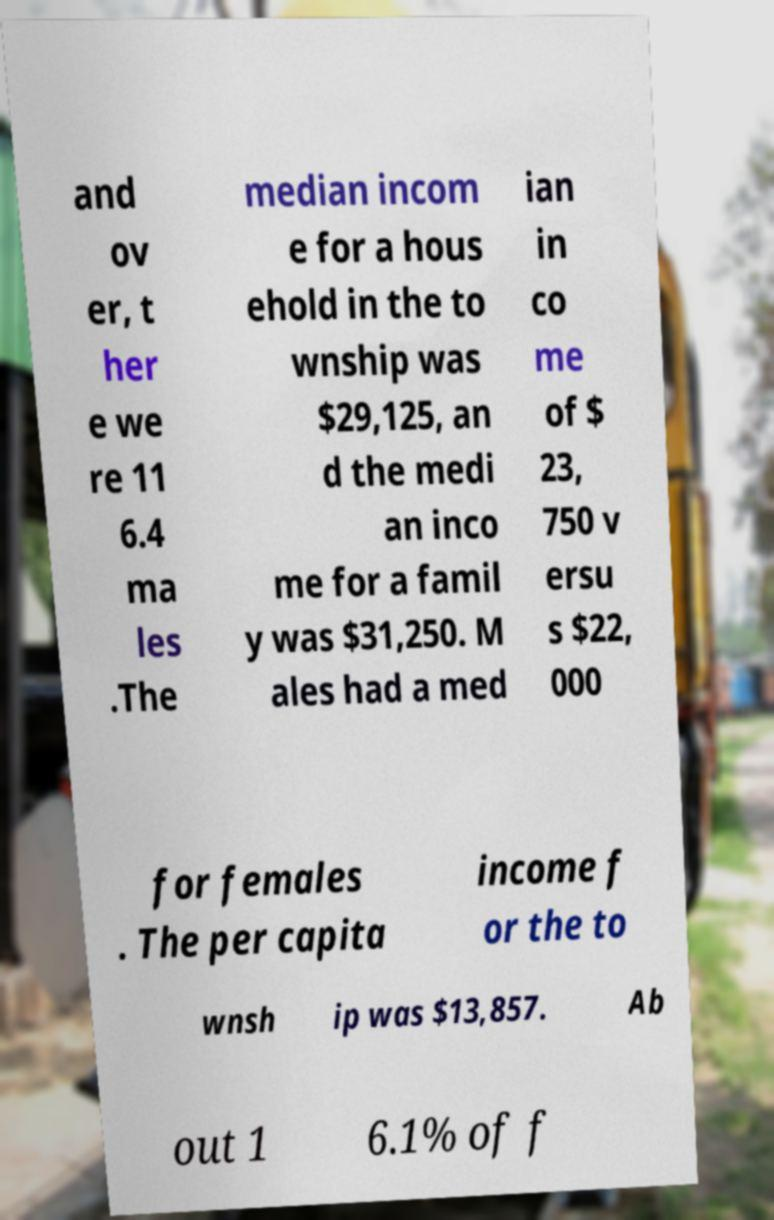Please read and relay the text visible in this image. What does it say? and ov er, t her e we re 11 6.4 ma les .The median incom e for a hous ehold in the to wnship was $29,125, an d the medi an inco me for a famil y was $31,250. M ales had a med ian in co me of $ 23, 750 v ersu s $22, 000 for females . The per capita income f or the to wnsh ip was $13,857. Ab out 1 6.1% of f 